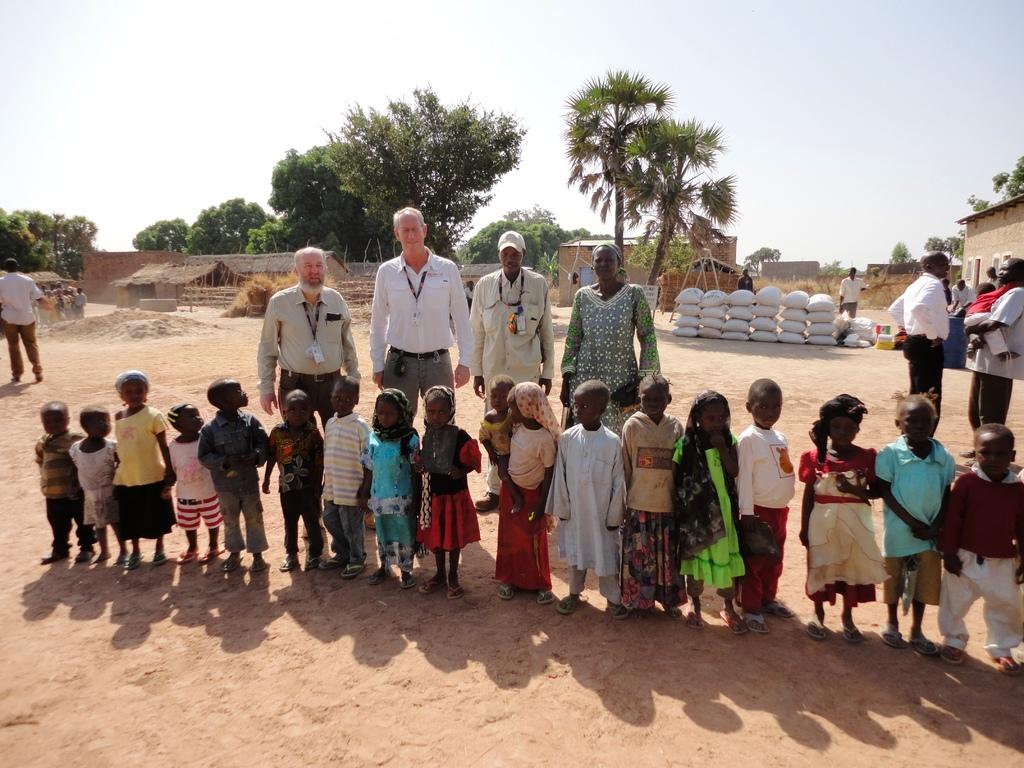What are the people in the image doing? The people in the image are standing on the ground. What objects can be seen near the people? There are bags visible in the image. What type of structure is present in the image? There is a shed in the image. What type of terrain is visible in the image? Sand is present in the image. What type of buildings can be seen in the image? There are houses in the image. What type of vegetation is visible in the image? Trees are visible in the image. What part of the natural environment is visible in the image? The sky is visible in the image. What type of parcel is being delivered to the achiever in the image? There is no achiever or parcel present in the image. 